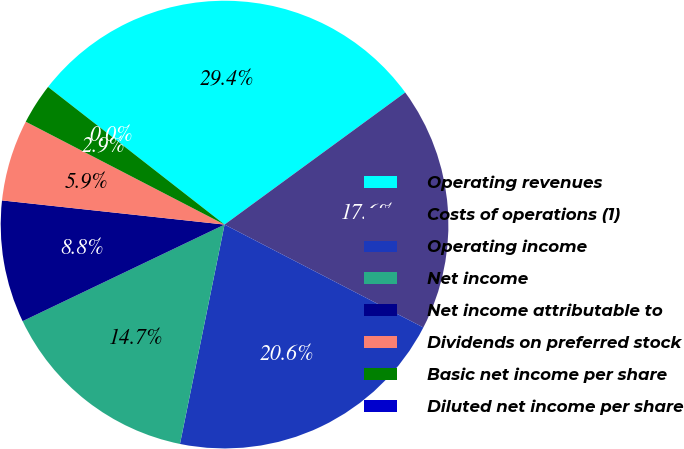Convert chart. <chart><loc_0><loc_0><loc_500><loc_500><pie_chart><fcel>Operating revenues<fcel>Costs of operations (1)<fcel>Operating income<fcel>Net income<fcel>Net income attributable to<fcel>Dividends on preferred stock<fcel>Basic net income per share<fcel>Diluted net income per share<nl><fcel>29.41%<fcel>17.65%<fcel>20.59%<fcel>14.71%<fcel>8.82%<fcel>5.88%<fcel>2.94%<fcel>0.0%<nl></chart> 